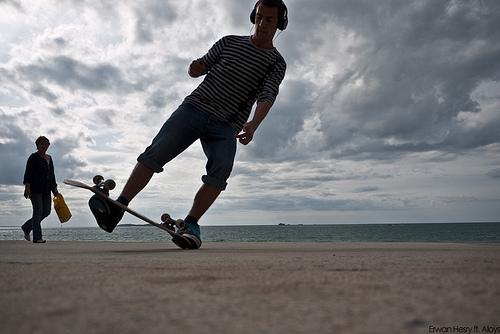What is the person in the background carrying?
Concise answer only. Bag. What's on the boy's ears?
Give a very brief answer. Headphones. Can you see water?
Give a very brief answer. Yes. 